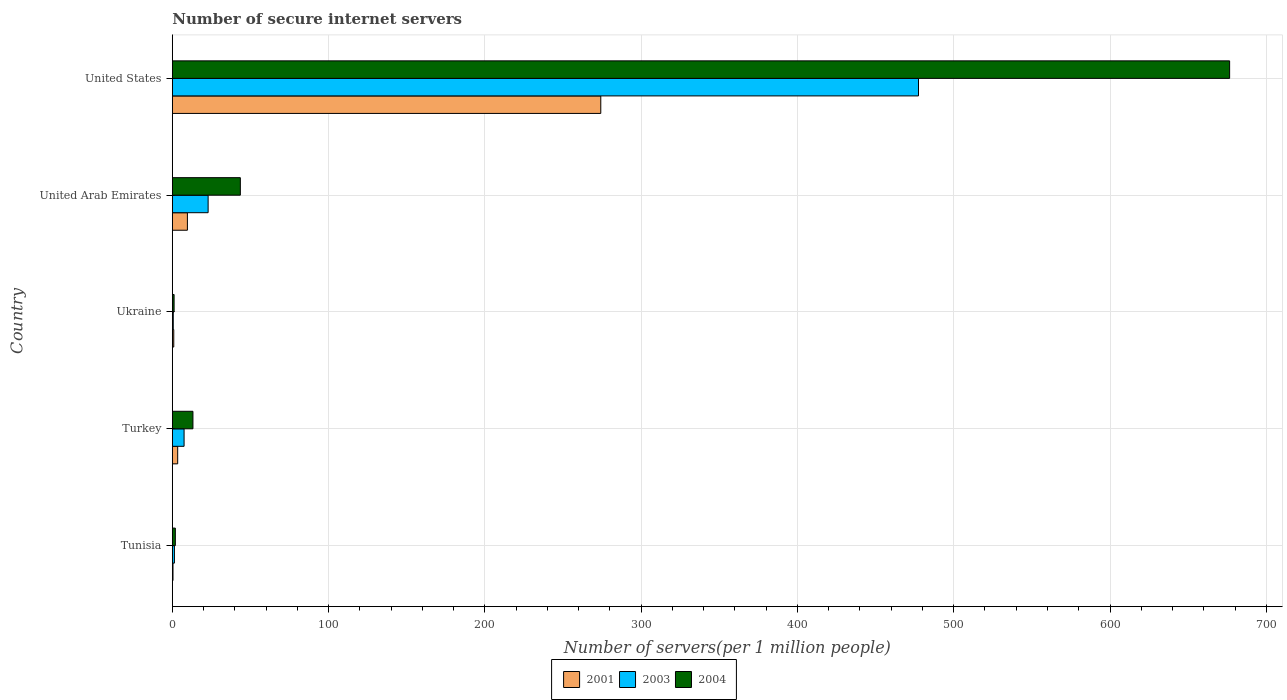Are the number of bars per tick equal to the number of legend labels?
Your response must be concise. Yes. Are the number of bars on each tick of the Y-axis equal?
Your response must be concise. Yes. How many bars are there on the 4th tick from the bottom?
Offer a terse response. 3. What is the label of the 3rd group of bars from the top?
Your response must be concise. Ukraine. In how many cases, is the number of bars for a given country not equal to the number of legend labels?
Give a very brief answer. 0. What is the number of secure internet servers in 2001 in Turkey?
Offer a terse response. 3.41. Across all countries, what is the maximum number of secure internet servers in 2004?
Provide a succinct answer. 676.55. Across all countries, what is the minimum number of secure internet servers in 2003?
Ensure brevity in your answer.  0.59. In which country was the number of secure internet servers in 2003 minimum?
Give a very brief answer. Ukraine. What is the total number of secure internet servers in 2003 in the graph?
Offer a terse response. 509.76. What is the difference between the number of secure internet servers in 2001 in Tunisia and that in Ukraine?
Ensure brevity in your answer.  -0.49. What is the difference between the number of secure internet servers in 2004 in Ukraine and the number of secure internet servers in 2001 in United Arab Emirates?
Ensure brevity in your answer.  -8.52. What is the average number of secure internet servers in 2001 per country?
Make the answer very short. 57.7. What is the difference between the number of secure internet servers in 2001 and number of secure internet servers in 2003 in United Arab Emirates?
Your response must be concise. -13.26. In how many countries, is the number of secure internet servers in 2001 greater than 60 ?
Your response must be concise. 1. What is the ratio of the number of secure internet servers in 2003 in Ukraine to that in United Arab Emirates?
Make the answer very short. 0.03. Is the number of secure internet servers in 2004 in Ukraine less than that in United States?
Keep it short and to the point. Yes. What is the difference between the highest and the second highest number of secure internet servers in 2004?
Offer a very short reply. 633.04. What is the difference between the highest and the lowest number of secure internet servers in 2003?
Provide a short and direct response. 476.87. Is the sum of the number of secure internet servers in 2004 in Tunisia and Turkey greater than the maximum number of secure internet servers in 2001 across all countries?
Offer a terse response. No. What does the 3rd bar from the bottom in United States represents?
Keep it short and to the point. 2004. Is it the case that in every country, the sum of the number of secure internet servers in 2001 and number of secure internet servers in 2004 is greater than the number of secure internet servers in 2003?
Provide a short and direct response. Yes. Are all the bars in the graph horizontal?
Your answer should be very brief. Yes. What is the difference between two consecutive major ticks on the X-axis?
Your answer should be compact. 100. Are the values on the major ticks of X-axis written in scientific E-notation?
Give a very brief answer. No. Does the graph contain any zero values?
Provide a succinct answer. No. Where does the legend appear in the graph?
Provide a short and direct response. Bottom center. How are the legend labels stacked?
Give a very brief answer. Horizontal. What is the title of the graph?
Your answer should be compact. Number of secure internet servers. Does "1971" appear as one of the legend labels in the graph?
Keep it short and to the point. No. What is the label or title of the X-axis?
Give a very brief answer. Number of servers(per 1 million people). What is the label or title of the Y-axis?
Provide a short and direct response. Country. What is the Number of servers(per 1 million people) of 2001 in Tunisia?
Your answer should be compact. 0.41. What is the Number of servers(per 1 million people) of 2003 in Tunisia?
Ensure brevity in your answer.  1.32. What is the Number of servers(per 1 million people) of 2004 in Tunisia?
Your response must be concise. 1.91. What is the Number of servers(per 1 million people) of 2001 in Turkey?
Offer a terse response. 3.41. What is the Number of servers(per 1 million people) of 2003 in Turkey?
Your response must be concise. 7.51. What is the Number of servers(per 1 million people) in 2004 in Turkey?
Your answer should be compact. 13.17. What is the Number of servers(per 1 million people) of 2001 in Ukraine?
Your answer should be very brief. 0.9. What is the Number of servers(per 1 million people) of 2003 in Ukraine?
Your answer should be very brief. 0.59. What is the Number of servers(per 1 million people) in 2004 in Ukraine?
Offer a very short reply. 1.12. What is the Number of servers(per 1 million people) of 2001 in United Arab Emirates?
Offer a terse response. 9.63. What is the Number of servers(per 1 million people) in 2003 in United Arab Emirates?
Offer a very short reply. 22.89. What is the Number of servers(per 1 million people) in 2004 in United Arab Emirates?
Your response must be concise. 43.51. What is the Number of servers(per 1 million people) of 2001 in United States?
Your answer should be compact. 274.16. What is the Number of servers(per 1 million people) in 2003 in United States?
Offer a terse response. 477.46. What is the Number of servers(per 1 million people) of 2004 in United States?
Offer a very short reply. 676.55. Across all countries, what is the maximum Number of servers(per 1 million people) of 2001?
Offer a very short reply. 274.16. Across all countries, what is the maximum Number of servers(per 1 million people) of 2003?
Offer a very short reply. 477.46. Across all countries, what is the maximum Number of servers(per 1 million people) in 2004?
Offer a terse response. 676.55. Across all countries, what is the minimum Number of servers(per 1 million people) in 2001?
Your answer should be very brief. 0.41. Across all countries, what is the minimum Number of servers(per 1 million people) in 2003?
Ensure brevity in your answer.  0.59. Across all countries, what is the minimum Number of servers(per 1 million people) of 2004?
Your response must be concise. 1.12. What is the total Number of servers(per 1 million people) in 2001 in the graph?
Provide a short and direct response. 288.52. What is the total Number of servers(per 1 million people) in 2003 in the graph?
Keep it short and to the point. 509.76. What is the total Number of servers(per 1 million people) in 2004 in the graph?
Your answer should be compact. 736.26. What is the difference between the Number of servers(per 1 million people) in 2001 in Tunisia and that in Turkey?
Your response must be concise. -3. What is the difference between the Number of servers(per 1 million people) of 2003 in Tunisia and that in Turkey?
Your response must be concise. -6.19. What is the difference between the Number of servers(per 1 million people) in 2004 in Tunisia and that in Turkey?
Provide a short and direct response. -11.26. What is the difference between the Number of servers(per 1 million people) in 2001 in Tunisia and that in Ukraine?
Keep it short and to the point. -0.49. What is the difference between the Number of servers(per 1 million people) in 2003 in Tunisia and that in Ukraine?
Keep it short and to the point. 0.74. What is the difference between the Number of servers(per 1 million people) in 2004 in Tunisia and that in Ukraine?
Your response must be concise. 0.8. What is the difference between the Number of servers(per 1 million people) of 2001 in Tunisia and that in United Arab Emirates?
Make the answer very short. -9.22. What is the difference between the Number of servers(per 1 million people) in 2003 in Tunisia and that in United Arab Emirates?
Offer a very short reply. -21.57. What is the difference between the Number of servers(per 1 million people) of 2004 in Tunisia and that in United Arab Emirates?
Ensure brevity in your answer.  -41.6. What is the difference between the Number of servers(per 1 million people) in 2001 in Tunisia and that in United States?
Your response must be concise. -273.74. What is the difference between the Number of servers(per 1 million people) in 2003 in Tunisia and that in United States?
Your answer should be very brief. -476.14. What is the difference between the Number of servers(per 1 million people) in 2004 in Tunisia and that in United States?
Your answer should be very brief. -674.64. What is the difference between the Number of servers(per 1 million people) in 2001 in Turkey and that in Ukraine?
Your response must be concise. 2.51. What is the difference between the Number of servers(per 1 million people) in 2003 in Turkey and that in Ukraine?
Keep it short and to the point. 6.92. What is the difference between the Number of servers(per 1 million people) of 2004 in Turkey and that in Ukraine?
Keep it short and to the point. 12.05. What is the difference between the Number of servers(per 1 million people) in 2001 in Turkey and that in United Arab Emirates?
Your answer should be very brief. -6.22. What is the difference between the Number of servers(per 1 million people) of 2003 in Turkey and that in United Arab Emirates?
Give a very brief answer. -15.38. What is the difference between the Number of servers(per 1 million people) in 2004 in Turkey and that in United Arab Emirates?
Your answer should be compact. -30.34. What is the difference between the Number of servers(per 1 million people) of 2001 in Turkey and that in United States?
Give a very brief answer. -270.74. What is the difference between the Number of servers(per 1 million people) in 2003 in Turkey and that in United States?
Keep it short and to the point. -469.95. What is the difference between the Number of servers(per 1 million people) in 2004 in Turkey and that in United States?
Your answer should be very brief. -663.38. What is the difference between the Number of servers(per 1 million people) in 2001 in Ukraine and that in United Arab Emirates?
Your answer should be compact. -8.73. What is the difference between the Number of servers(per 1 million people) of 2003 in Ukraine and that in United Arab Emirates?
Give a very brief answer. -22.31. What is the difference between the Number of servers(per 1 million people) in 2004 in Ukraine and that in United Arab Emirates?
Ensure brevity in your answer.  -42.39. What is the difference between the Number of servers(per 1 million people) in 2001 in Ukraine and that in United States?
Provide a succinct answer. -273.25. What is the difference between the Number of servers(per 1 million people) in 2003 in Ukraine and that in United States?
Your answer should be compact. -476.87. What is the difference between the Number of servers(per 1 million people) of 2004 in Ukraine and that in United States?
Offer a terse response. -675.43. What is the difference between the Number of servers(per 1 million people) of 2001 in United Arab Emirates and that in United States?
Keep it short and to the point. -264.52. What is the difference between the Number of servers(per 1 million people) in 2003 in United Arab Emirates and that in United States?
Provide a succinct answer. -454.57. What is the difference between the Number of servers(per 1 million people) of 2004 in United Arab Emirates and that in United States?
Ensure brevity in your answer.  -633.04. What is the difference between the Number of servers(per 1 million people) in 2001 in Tunisia and the Number of servers(per 1 million people) in 2003 in Turkey?
Offer a terse response. -7.09. What is the difference between the Number of servers(per 1 million people) in 2001 in Tunisia and the Number of servers(per 1 million people) in 2004 in Turkey?
Offer a terse response. -12.75. What is the difference between the Number of servers(per 1 million people) of 2003 in Tunisia and the Number of servers(per 1 million people) of 2004 in Turkey?
Offer a very short reply. -11.85. What is the difference between the Number of servers(per 1 million people) of 2001 in Tunisia and the Number of servers(per 1 million people) of 2003 in Ukraine?
Your answer should be very brief. -0.17. What is the difference between the Number of servers(per 1 million people) in 2001 in Tunisia and the Number of servers(per 1 million people) in 2004 in Ukraine?
Give a very brief answer. -0.7. What is the difference between the Number of servers(per 1 million people) of 2003 in Tunisia and the Number of servers(per 1 million people) of 2004 in Ukraine?
Provide a short and direct response. 0.2. What is the difference between the Number of servers(per 1 million people) in 2001 in Tunisia and the Number of servers(per 1 million people) in 2003 in United Arab Emirates?
Keep it short and to the point. -22.48. What is the difference between the Number of servers(per 1 million people) in 2001 in Tunisia and the Number of servers(per 1 million people) in 2004 in United Arab Emirates?
Offer a very short reply. -43.1. What is the difference between the Number of servers(per 1 million people) in 2003 in Tunisia and the Number of servers(per 1 million people) in 2004 in United Arab Emirates?
Keep it short and to the point. -42.19. What is the difference between the Number of servers(per 1 million people) in 2001 in Tunisia and the Number of servers(per 1 million people) in 2003 in United States?
Ensure brevity in your answer.  -477.04. What is the difference between the Number of servers(per 1 million people) of 2001 in Tunisia and the Number of servers(per 1 million people) of 2004 in United States?
Keep it short and to the point. -676.14. What is the difference between the Number of servers(per 1 million people) in 2003 in Tunisia and the Number of servers(per 1 million people) in 2004 in United States?
Provide a succinct answer. -675.23. What is the difference between the Number of servers(per 1 million people) of 2001 in Turkey and the Number of servers(per 1 million people) of 2003 in Ukraine?
Offer a very short reply. 2.83. What is the difference between the Number of servers(per 1 million people) in 2001 in Turkey and the Number of servers(per 1 million people) in 2004 in Ukraine?
Give a very brief answer. 2.3. What is the difference between the Number of servers(per 1 million people) of 2003 in Turkey and the Number of servers(per 1 million people) of 2004 in Ukraine?
Provide a succinct answer. 6.39. What is the difference between the Number of servers(per 1 million people) of 2001 in Turkey and the Number of servers(per 1 million people) of 2003 in United Arab Emirates?
Offer a terse response. -19.48. What is the difference between the Number of servers(per 1 million people) of 2001 in Turkey and the Number of servers(per 1 million people) of 2004 in United Arab Emirates?
Ensure brevity in your answer.  -40.1. What is the difference between the Number of servers(per 1 million people) in 2003 in Turkey and the Number of servers(per 1 million people) in 2004 in United Arab Emirates?
Your answer should be very brief. -36. What is the difference between the Number of servers(per 1 million people) in 2001 in Turkey and the Number of servers(per 1 million people) in 2003 in United States?
Ensure brevity in your answer.  -474.04. What is the difference between the Number of servers(per 1 million people) of 2001 in Turkey and the Number of servers(per 1 million people) of 2004 in United States?
Give a very brief answer. -673.14. What is the difference between the Number of servers(per 1 million people) in 2003 in Turkey and the Number of servers(per 1 million people) in 2004 in United States?
Keep it short and to the point. -669.04. What is the difference between the Number of servers(per 1 million people) in 2001 in Ukraine and the Number of servers(per 1 million people) in 2003 in United Arab Emirates?
Your answer should be very brief. -21.99. What is the difference between the Number of servers(per 1 million people) in 2001 in Ukraine and the Number of servers(per 1 million people) in 2004 in United Arab Emirates?
Your response must be concise. -42.61. What is the difference between the Number of servers(per 1 million people) of 2003 in Ukraine and the Number of servers(per 1 million people) of 2004 in United Arab Emirates?
Provide a succinct answer. -42.93. What is the difference between the Number of servers(per 1 million people) in 2001 in Ukraine and the Number of servers(per 1 million people) in 2003 in United States?
Ensure brevity in your answer.  -476.55. What is the difference between the Number of servers(per 1 million people) of 2001 in Ukraine and the Number of servers(per 1 million people) of 2004 in United States?
Give a very brief answer. -675.65. What is the difference between the Number of servers(per 1 million people) in 2003 in Ukraine and the Number of servers(per 1 million people) in 2004 in United States?
Keep it short and to the point. -675.97. What is the difference between the Number of servers(per 1 million people) in 2001 in United Arab Emirates and the Number of servers(per 1 million people) in 2003 in United States?
Keep it short and to the point. -467.82. What is the difference between the Number of servers(per 1 million people) of 2001 in United Arab Emirates and the Number of servers(per 1 million people) of 2004 in United States?
Provide a short and direct response. -666.92. What is the difference between the Number of servers(per 1 million people) in 2003 in United Arab Emirates and the Number of servers(per 1 million people) in 2004 in United States?
Offer a terse response. -653.66. What is the average Number of servers(per 1 million people) in 2001 per country?
Your response must be concise. 57.7. What is the average Number of servers(per 1 million people) in 2003 per country?
Your response must be concise. 101.95. What is the average Number of servers(per 1 million people) in 2004 per country?
Provide a short and direct response. 147.25. What is the difference between the Number of servers(per 1 million people) of 2001 and Number of servers(per 1 million people) of 2003 in Tunisia?
Keep it short and to the point. -0.91. What is the difference between the Number of servers(per 1 million people) of 2001 and Number of servers(per 1 million people) of 2004 in Tunisia?
Your answer should be compact. -1.5. What is the difference between the Number of servers(per 1 million people) of 2003 and Number of servers(per 1 million people) of 2004 in Tunisia?
Ensure brevity in your answer.  -0.59. What is the difference between the Number of servers(per 1 million people) of 2001 and Number of servers(per 1 million people) of 2003 in Turkey?
Provide a succinct answer. -4.1. What is the difference between the Number of servers(per 1 million people) of 2001 and Number of servers(per 1 million people) of 2004 in Turkey?
Keep it short and to the point. -9.76. What is the difference between the Number of servers(per 1 million people) of 2003 and Number of servers(per 1 million people) of 2004 in Turkey?
Offer a very short reply. -5.66. What is the difference between the Number of servers(per 1 million people) of 2001 and Number of servers(per 1 million people) of 2003 in Ukraine?
Your answer should be compact. 0.32. What is the difference between the Number of servers(per 1 million people) in 2001 and Number of servers(per 1 million people) in 2004 in Ukraine?
Provide a succinct answer. -0.21. What is the difference between the Number of servers(per 1 million people) in 2003 and Number of servers(per 1 million people) in 2004 in Ukraine?
Provide a succinct answer. -0.53. What is the difference between the Number of servers(per 1 million people) in 2001 and Number of servers(per 1 million people) in 2003 in United Arab Emirates?
Keep it short and to the point. -13.26. What is the difference between the Number of servers(per 1 million people) of 2001 and Number of servers(per 1 million people) of 2004 in United Arab Emirates?
Your answer should be very brief. -33.88. What is the difference between the Number of servers(per 1 million people) in 2003 and Number of servers(per 1 million people) in 2004 in United Arab Emirates?
Make the answer very short. -20.62. What is the difference between the Number of servers(per 1 million people) in 2001 and Number of servers(per 1 million people) in 2003 in United States?
Offer a terse response. -203.3. What is the difference between the Number of servers(per 1 million people) of 2001 and Number of servers(per 1 million people) of 2004 in United States?
Your answer should be very brief. -402.4. What is the difference between the Number of servers(per 1 million people) in 2003 and Number of servers(per 1 million people) in 2004 in United States?
Your answer should be very brief. -199.1. What is the ratio of the Number of servers(per 1 million people) in 2001 in Tunisia to that in Turkey?
Make the answer very short. 0.12. What is the ratio of the Number of servers(per 1 million people) in 2003 in Tunisia to that in Turkey?
Your answer should be compact. 0.18. What is the ratio of the Number of servers(per 1 million people) in 2004 in Tunisia to that in Turkey?
Make the answer very short. 0.15. What is the ratio of the Number of servers(per 1 million people) of 2001 in Tunisia to that in Ukraine?
Offer a very short reply. 0.46. What is the ratio of the Number of servers(per 1 million people) in 2003 in Tunisia to that in Ukraine?
Your answer should be compact. 2.26. What is the ratio of the Number of servers(per 1 million people) of 2004 in Tunisia to that in Ukraine?
Offer a terse response. 1.71. What is the ratio of the Number of servers(per 1 million people) of 2001 in Tunisia to that in United Arab Emirates?
Your answer should be compact. 0.04. What is the ratio of the Number of servers(per 1 million people) in 2003 in Tunisia to that in United Arab Emirates?
Make the answer very short. 0.06. What is the ratio of the Number of servers(per 1 million people) of 2004 in Tunisia to that in United Arab Emirates?
Your answer should be very brief. 0.04. What is the ratio of the Number of servers(per 1 million people) of 2001 in Tunisia to that in United States?
Give a very brief answer. 0. What is the ratio of the Number of servers(per 1 million people) in 2003 in Tunisia to that in United States?
Make the answer very short. 0. What is the ratio of the Number of servers(per 1 million people) of 2004 in Tunisia to that in United States?
Ensure brevity in your answer.  0. What is the ratio of the Number of servers(per 1 million people) of 2001 in Turkey to that in Ukraine?
Provide a short and direct response. 3.78. What is the ratio of the Number of servers(per 1 million people) of 2003 in Turkey to that in Ukraine?
Offer a very short reply. 12.82. What is the ratio of the Number of servers(per 1 million people) in 2004 in Turkey to that in Ukraine?
Make the answer very short. 11.79. What is the ratio of the Number of servers(per 1 million people) of 2001 in Turkey to that in United Arab Emirates?
Offer a terse response. 0.35. What is the ratio of the Number of servers(per 1 million people) of 2003 in Turkey to that in United Arab Emirates?
Make the answer very short. 0.33. What is the ratio of the Number of servers(per 1 million people) of 2004 in Turkey to that in United Arab Emirates?
Offer a terse response. 0.3. What is the ratio of the Number of servers(per 1 million people) in 2001 in Turkey to that in United States?
Make the answer very short. 0.01. What is the ratio of the Number of servers(per 1 million people) in 2003 in Turkey to that in United States?
Your answer should be compact. 0.02. What is the ratio of the Number of servers(per 1 million people) of 2004 in Turkey to that in United States?
Offer a very short reply. 0.02. What is the ratio of the Number of servers(per 1 million people) in 2001 in Ukraine to that in United Arab Emirates?
Keep it short and to the point. 0.09. What is the ratio of the Number of servers(per 1 million people) in 2003 in Ukraine to that in United Arab Emirates?
Offer a terse response. 0.03. What is the ratio of the Number of servers(per 1 million people) in 2004 in Ukraine to that in United Arab Emirates?
Make the answer very short. 0.03. What is the ratio of the Number of servers(per 1 million people) in 2001 in Ukraine to that in United States?
Make the answer very short. 0. What is the ratio of the Number of servers(per 1 million people) in 2003 in Ukraine to that in United States?
Offer a terse response. 0. What is the ratio of the Number of servers(per 1 million people) in 2004 in Ukraine to that in United States?
Provide a succinct answer. 0. What is the ratio of the Number of servers(per 1 million people) of 2001 in United Arab Emirates to that in United States?
Your answer should be very brief. 0.04. What is the ratio of the Number of servers(per 1 million people) of 2003 in United Arab Emirates to that in United States?
Offer a very short reply. 0.05. What is the ratio of the Number of servers(per 1 million people) of 2004 in United Arab Emirates to that in United States?
Provide a short and direct response. 0.06. What is the difference between the highest and the second highest Number of servers(per 1 million people) of 2001?
Your answer should be very brief. 264.52. What is the difference between the highest and the second highest Number of servers(per 1 million people) of 2003?
Provide a succinct answer. 454.57. What is the difference between the highest and the second highest Number of servers(per 1 million people) in 2004?
Ensure brevity in your answer.  633.04. What is the difference between the highest and the lowest Number of servers(per 1 million people) in 2001?
Keep it short and to the point. 273.74. What is the difference between the highest and the lowest Number of servers(per 1 million people) of 2003?
Ensure brevity in your answer.  476.87. What is the difference between the highest and the lowest Number of servers(per 1 million people) of 2004?
Ensure brevity in your answer.  675.43. 